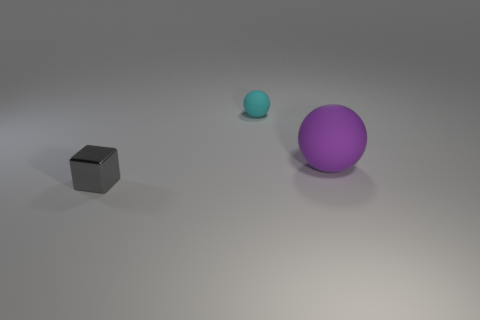Add 3 large purple objects. How many objects exist? 6 Subtract all purple balls. How many balls are left? 1 Subtract all balls. How many objects are left? 1 Add 2 purple cubes. How many purple cubes exist? 2 Subtract 1 purple spheres. How many objects are left? 2 Subtract 1 blocks. How many blocks are left? 0 Subtract all cyan balls. Subtract all gray cubes. How many balls are left? 1 Subtract all purple cylinders. How many red cubes are left? 0 Subtract all tiny cyan objects. Subtract all tiny gray blocks. How many objects are left? 1 Add 3 purple matte objects. How many purple matte objects are left? 4 